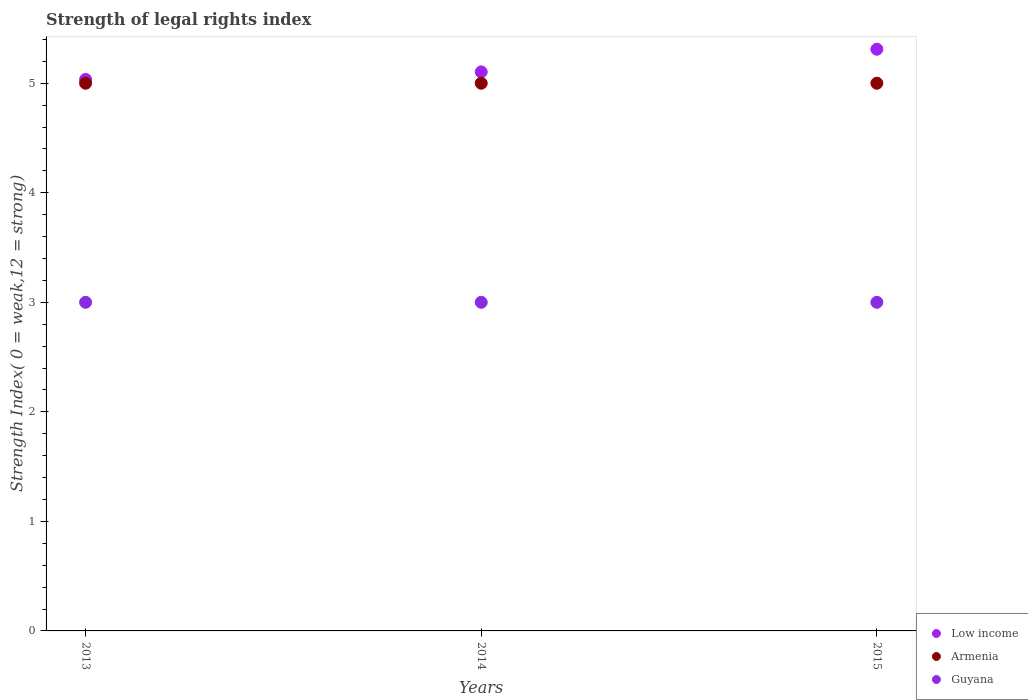How many different coloured dotlines are there?
Keep it short and to the point. 3. Is the number of dotlines equal to the number of legend labels?
Ensure brevity in your answer.  Yes. What is the strength index in Armenia in 2015?
Make the answer very short. 5. Across all years, what is the maximum strength index in Low income?
Offer a very short reply. 5.31. Across all years, what is the minimum strength index in Guyana?
Provide a succinct answer. 3. In which year was the strength index in Armenia maximum?
Your answer should be compact. 2013. What is the total strength index in Guyana in the graph?
Keep it short and to the point. 9. What is the difference between the strength index in Armenia in 2014 and that in 2015?
Ensure brevity in your answer.  0. What is the difference between the strength index in Low income in 2013 and the strength index in Guyana in 2014?
Your answer should be compact. 2.03. What is the average strength index in Guyana per year?
Provide a short and direct response. 3. In the year 2015, what is the difference between the strength index in Low income and strength index in Armenia?
Offer a very short reply. 0.31. In how many years, is the strength index in Low income greater than 3.4?
Provide a succinct answer. 3. What is the ratio of the strength index in Guyana in 2013 to that in 2015?
Keep it short and to the point. 1. Is the difference between the strength index in Low income in 2013 and 2015 greater than the difference between the strength index in Armenia in 2013 and 2015?
Give a very brief answer. No. What is the difference between the highest and the second highest strength index in Guyana?
Your answer should be compact. 0. What is the difference between the highest and the lowest strength index in Armenia?
Your response must be concise. 0. In how many years, is the strength index in Low income greater than the average strength index in Low income taken over all years?
Make the answer very short. 1. Is the sum of the strength index in Low income in 2014 and 2015 greater than the maximum strength index in Guyana across all years?
Your answer should be very brief. Yes. Is the strength index in Armenia strictly greater than the strength index in Guyana over the years?
Give a very brief answer. Yes. Is the strength index in Guyana strictly less than the strength index in Low income over the years?
Make the answer very short. Yes. How many dotlines are there?
Your answer should be compact. 3. How many years are there in the graph?
Your answer should be very brief. 3. What is the difference between two consecutive major ticks on the Y-axis?
Provide a succinct answer. 1. Are the values on the major ticks of Y-axis written in scientific E-notation?
Offer a very short reply. No. Does the graph contain grids?
Your response must be concise. No. How many legend labels are there?
Keep it short and to the point. 3. What is the title of the graph?
Ensure brevity in your answer.  Strength of legal rights index. What is the label or title of the Y-axis?
Ensure brevity in your answer.  Strength Index( 0 = weak,12 = strong). What is the Strength Index( 0 = weak,12 = strong) in Low income in 2013?
Your response must be concise. 5.03. What is the Strength Index( 0 = weak,12 = strong) in Guyana in 2013?
Offer a very short reply. 3. What is the Strength Index( 0 = weak,12 = strong) of Low income in 2014?
Your response must be concise. 5.1. What is the Strength Index( 0 = weak,12 = strong) in Armenia in 2014?
Ensure brevity in your answer.  5. What is the Strength Index( 0 = weak,12 = strong) in Guyana in 2014?
Your answer should be compact. 3. What is the Strength Index( 0 = weak,12 = strong) in Low income in 2015?
Keep it short and to the point. 5.31. What is the Strength Index( 0 = weak,12 = strong) in Armenia in 2015?
Your response must be concise. 5. Across all years, what is the maximum Strength Index( 0 = weak,12 = strong) of Low income?
Ensure brevity in your answer.  5.31. Across all years, what is the maximum Strength Index( 0 = weak,12 = strong) in Armenia?
Provide a short and direct response. 5. Across all years, what is the minimum Strength Index( 0 = weak,12 = strong) of Low income?
Provide a succinct answer. 5.03. Across all years, what is the minimum Strength Index( 0 = weak,12 = strong) of Armenia?
Your response must be concise. 5. What is the total Strength Index( 0 = weak,12 = strong) of Low income in the graph?
Provide a succinct answer. 15.45. What is the total Strength Index( 0 = weak,12 = strong) in Guyana in the graph?
Offer a terse response. 9. What is the difference between the Strength Index( 0 = weak,12 = strong) of Low income in 2013 and that in 2014?
Your answer should be very brief. -0.07. What is the difference between the Strength Index( 0 = weak,12 = strong) in Armenia in 2013 and that in 2014?
Provide a succinct answer. 0. What is the difference between the Strength Index( 0 = weak,12 = strong) in Low income in 2013 and that in 2015?
Give a very brief answer. -0.28. What is the difference between the Strength Index( 0 = weak,12 = strong) of Guyana in 2013 and that in 2015?
Ensure brevity in your answer.  0. What is the difference between the Strength Index( 0 = weak,12 = strong) in Low income in 2014 and that in 2015?
Keep it short and to the point. -0.21. What is the difference between the Strength Index( 0 = weak,12 = strong) in Low income in 2013 and the Strength Index( 0 = weak,12 = strong) in Armenia in 2014?
Your response must be concise. 0.03. What is the difference between the Strength Index( 0 = weak,12 = strong) of Low income in 2013 and the Strength Index( 0 = weak,12 = strong) of Guyana in 2014?
Provide a short and direct response. 2.03. What is the difference between the Strength Index( 0 = weak,12 = strong) of Armenia in 2013 and the Strength Index( 0 = weak,12 = strong) of Guyana in 2014?
Provide a succinct answer. 2. What is the difference between the Strength Index( 0 = weak,12 = strong) in Low income in 2013 and the Strength Index( 0 = weak,12 = strong) in Armenia in 2015?
Ensure brevity in your answer.  0.03. What is the difference between the Strength Index( 0 = weak,12 = strong) in Low income in 2013 and the Strength Index( 0 = weak,12 = strong) in Guyana in 2015?
Provide a succinct answer. 2.03. What is the difference between the Strength Index( 0 = weak,12 = strong) in Armenia in 2013 and the Strength Index( 0 = weak,12 = strong) in Guyana in 2015?
Provide a succinct answer. 2. What is the difference between the Strength Index( 0 = weak,12 = strong) in Low income in 2014 and the Strength Index( 0 = weak,12 = strong) in Armenia in 2015?
Your response must be concise. 0.1. What is the difference between the Strength Index( 0 = weak,12 = strong) in Low income in 2014 and the Strength Index( 0 = weak,12 = strong) in Guyana in 2015?
Give a very brief answer. 2.1. What is the average Strength Index( 0 = weak,12 = strong) of Low income per year?
Ensure brevity in your answer.  5.15. In the year 2013, what is the difference between the Strength Index( 0 = weak,12 = strong) of Low income and Strength Index( 0 = weak,12 = strong) of Armenia?
Your answer should be compact. 0.03. In the year 2013, what is the difference between the Strength Index( 0 = weak,12 = strong) of Low income and Strength Index( 0 = weak,12 = strong) of Guyana?
Give a very brief answer. 2.03. In the year 2013, what is the difference between the Strength Index( 0 = weak,12 = strong) of Armenia and Strength Index( 0 = weak,12 = strong) of Guyana?
Make the answer very short. 2. In the year 2014, what is the difference between the Strength Index( 0 = weak,12 = strong) in Low income and Strength Index( 0 = weak,12 = strong) in Armenia?
Make the answer very short. 0.1. In the year 2014, what is the difference between the Strength Index( 0 = weak,12 = strong) of Low income and Strength Index( 0 = weak,12 = strong) of Guyana?
Offer a terse response. 2.1. In the year 2014, what is the difference between the Strength Index( 0 = weak,12 = strong) in Armenia and Strength Index( 0 = weak,12 = strong) in Guyana?
Offer a terse response. 2. In the year 2015, what is the difference between the Strength Index( 0 = weak,12 = strong) in Low income and Strength Index( 0 = weak,12 = strong) in Armenia?
Your response must be concise. 0.31. In the year 2015, what is the difference between the Strength Index( 0 = weak,12 = strong) in Low income and Strength Index( 0 = weak,12 = strong) in Guyana?
Your answer should be compact. 2.31. What is the ratio of the Strength Index( 0 = weak,12 = strong) of Low income in 2013 to that in 2014?
Your answer should be very brief. 0.99. What is the ratio of the Strength Index( 0 = weak,12 = strong) of Armenia in 2013 to that in 2014?
Your response must be concise. 1. What is the ratio of the Strength Index( 0 = weak,12 = strong) in Low income in 2013 to that in 2015?
Offer a very short reply. 0.95. What is the ratio of the Strength Index( 0 = weak,12 = strong) in Low income in 2014 to that in 2015?
Your answer should be compact. 0.96. What is the ratio of the Strength Index( 0 = weak,12 = strong) of Armenia in 2014 to that in 2015?
Your answer should be compact. 1. What is the difference between the highest and the second highest Strength Index( 0 = weak,12 = strong) of Low income?
Offer a terse response. 0.21. What is the difference between the highest and the second highest Strength Index( 0 = weak,12 = strong) of Armenia?
Offer a terse response. 0. What is the difference between the highest and the lowest Strength Index( 0 = weak,12 = strong) of Low income?
Offer a terse response. 0.28. What is the difference between the highest and the lowest Strength Index( 0 = weak,12 = strong) of Armenia?
Provide a short and direct response. 0. What is the difference between the highest and the lowest Strength Index( 0 = weak,12 = strong) in Guyana?
Your answer should be compact. 0. 